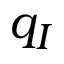Convert formula to latex. <formula><loc_0><loc_0><loc_500><loc_500>q _ { I }</formula> 